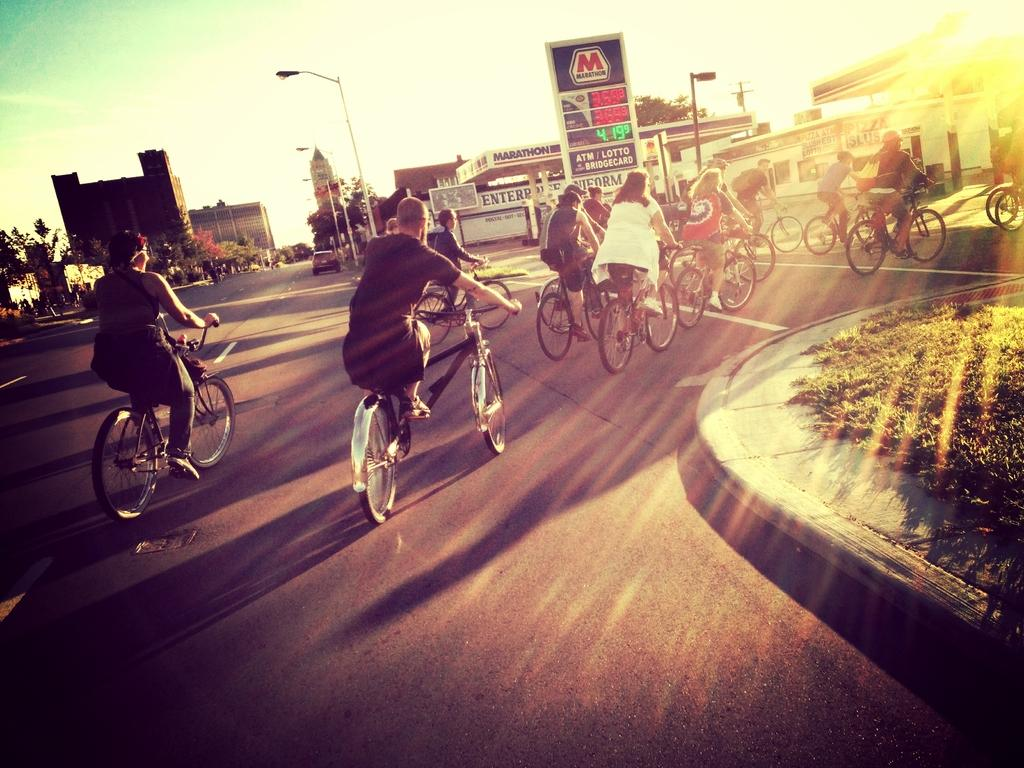What are the people in the image doing? The people in the image are riding bicycles on the road. What type of vegetation can be seen in the image? There is grass visible in the image. What can be seen in the background of the image? There are buildings, lights on poles, a board, a car, trees, and the sky visible in the background. What type of creature is sitting on the engine of the car in the image? There is no creature sitting on the engine of the car in the image, as there is no car engine visible. 